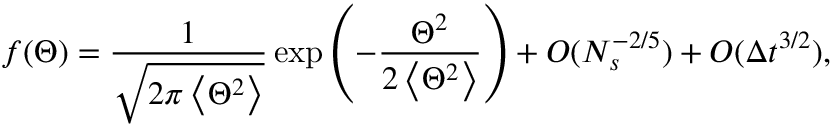<formula> <loc_0><loc_0><loc_500><loc_500>f ( \Theta ) = \frac { 1 } { \sqrt { 2 \pi \left < \Theta ^ { 2 } \right > } } \exp \left ( - \frac { \Theta ^ { 2 } } { 2 \left < \Theta ^ { 2 } \right > } \right ) + O ( N _ { s } ^ { - 2 / 5 } ) + O ( \Delta t ^ { 3 / 2 } ) ,</formula> 